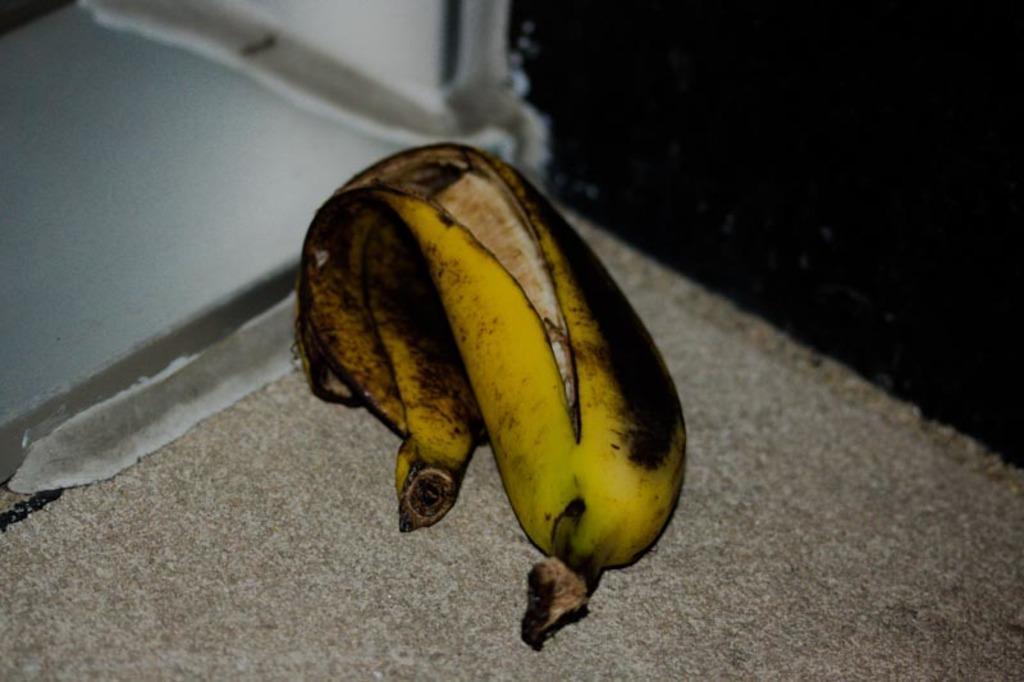In one or two sentences, can you explain what this image depicts? In this image there is a banana on the floor. 